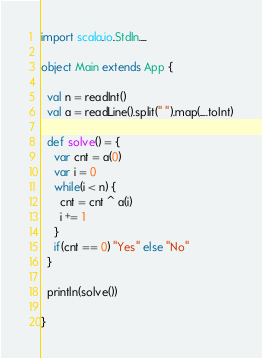<code> <loc_0><loc_0><loc_500><loc_500><_Scala_>import scala.io.StdIn._

object Main extends App {

  val n = readInt()
  val a = readLine().split(" ").map(_.toInt)

  def solve() = {
    var cnt = a(0)
    var i = 0
    while(i < n) {
      cnt = cnt ^ a(i)
      i += 1
    }
    if(cnt == 0) "Yes" else "No"
  }

  println(solve())

}

</code> 